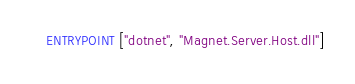<code> <loc_0><loc_0><loc_500><loc_500><_Dockerfile_>ENTRYPOINT ["dotnet", "Magnet.Server.Host.dll"]
</code> 